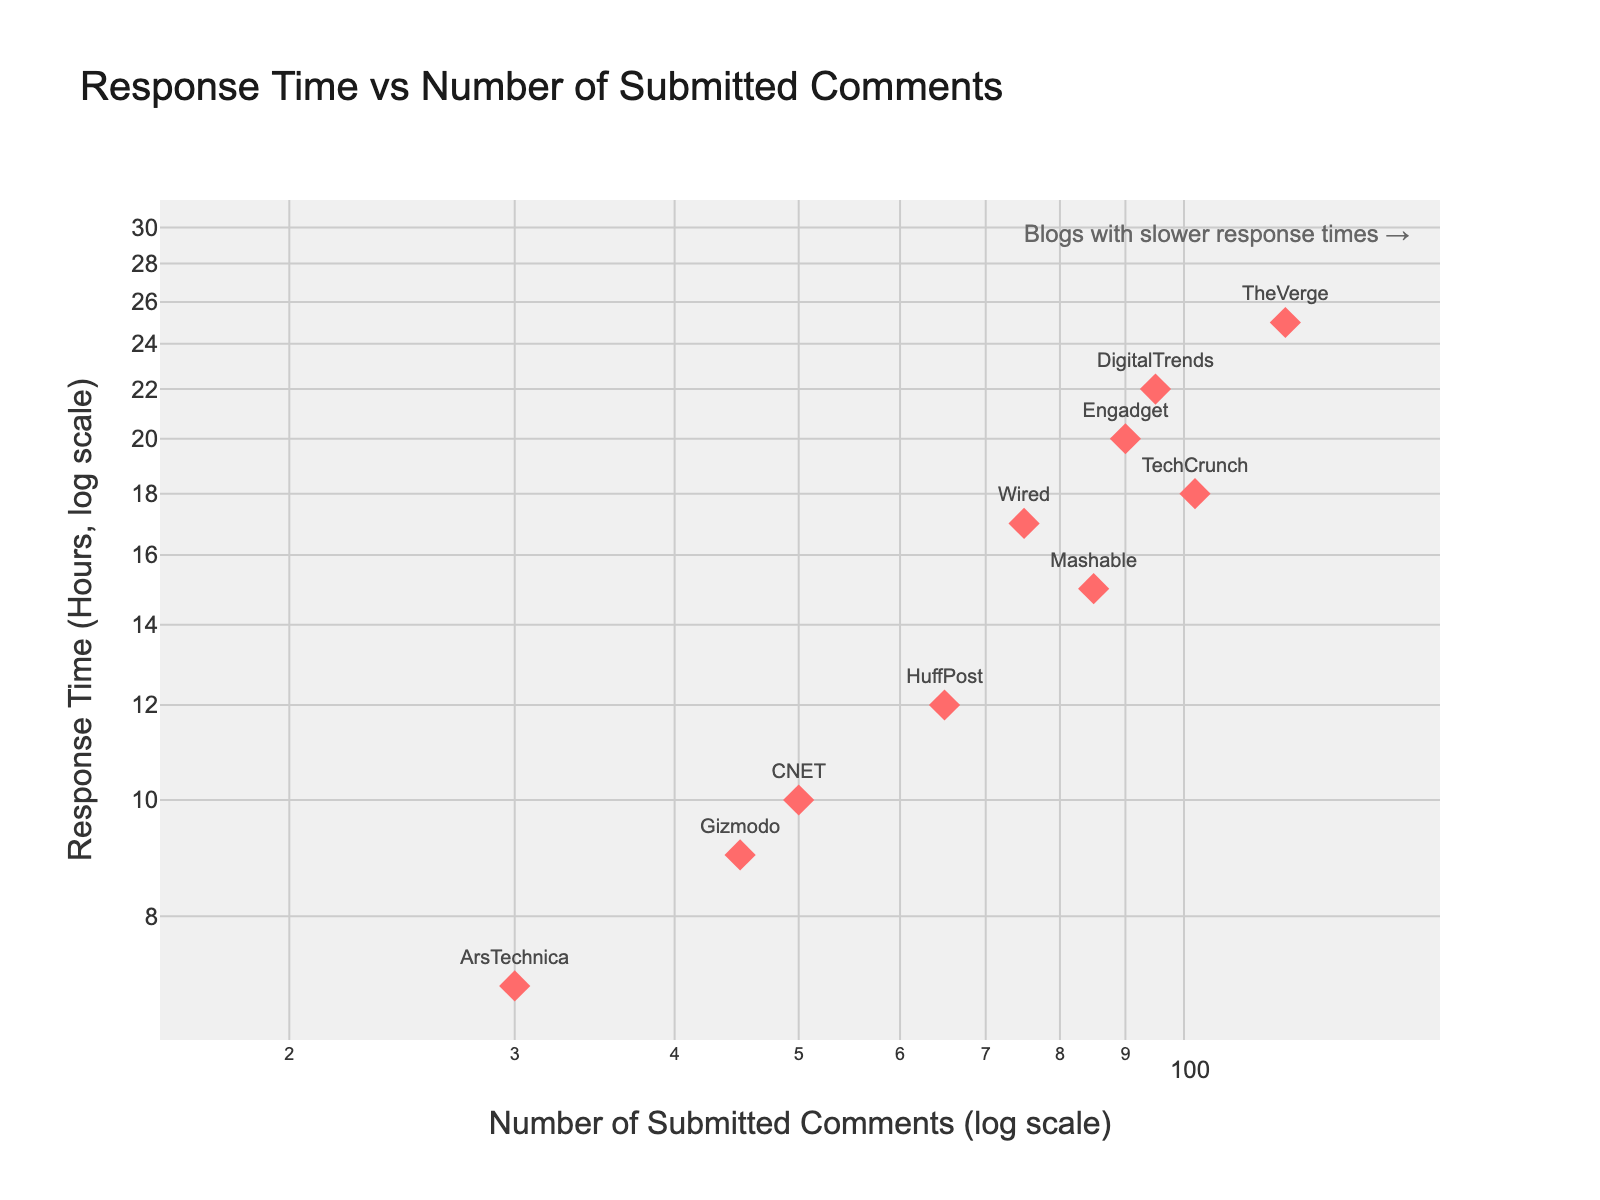What's the title of the scatter plot? The title of a figure is typically located at the top and is designed to give an overview of what the plot represents. Here, the title says "Response Time vs Number of Submitted Comments." This indicates that the plot shows a relationship between the two variables.
Answer: Response Time vs Number of Submitted Comments What do the x-axis and y-axis represent? The axes on a scatter plot typically label the variables being compared. In this figure, the x-axis represents the 'Number of Submitted Comments' on a log scale, while the y-axis represents 'Response Time (Hours)' also on a log scale.
Answer: x-axis: Number of Submitted Comments, y-axis: Response Time (Hours) Which blog has the highest number of submitted comments? By looking at the position on the x-axis, the blog farthest to the right has the highest number of submitted comments. This position is occupied by "TheVerge."
Answer: TheVerge What is the relationship indicated by the annotation "Blogs with slower response times →"? Annotations in plots provide additional context. The arrow points toward the upper part of the plot, which means blogs with higher values on the y-axis have slower response times.
Answer: Higher values on the y-axis indicate slower response times Which blog has the fastest response time? To find the fastest response time, look for the blog positioned lowest on the y-axis. This position is occupied by "ArsTechnica."
Answer: ArsTechnica What is the approximate range of submitted comments in the plot? The x-axis range is determined by the log scale values visible on the plot. The range approximately spans from 30 to 120 submitted comments.
Answer: 30 to 120 Which blog has both a high number of submitted comments and a fast response time? A blog that is high on the x-axis and low on the y-axis fits the description. "TechCrunch," positioned high on the x-axis and relatively low on the y-axis, fulfills this.
Answer: TechCrunch What is the number of submitted comments and response time for "Gizmodo"? By locating "Gizmodo" on the plot, it is easy to read the x and y coordinates which are approximately 45 submitted comments and 9 hours response time.
Answer: 45 submitted comments and 9 hours response time Which blog is positioned between "Mashable" and "Engadget" in terms of submitted comments? On the x-axis, find the position of "Mashable" and "Engadget" and identify the blog that falls in between them. "CNET" is positioned between these two.
Answer: CNET How does the response time of "HuffPost" compare to "Wired"? Compare their positions on the y-axis. "HuffPost" is slightly below "Wired," indicating a faster response time.
Answer: HuffPost has a faster response time 